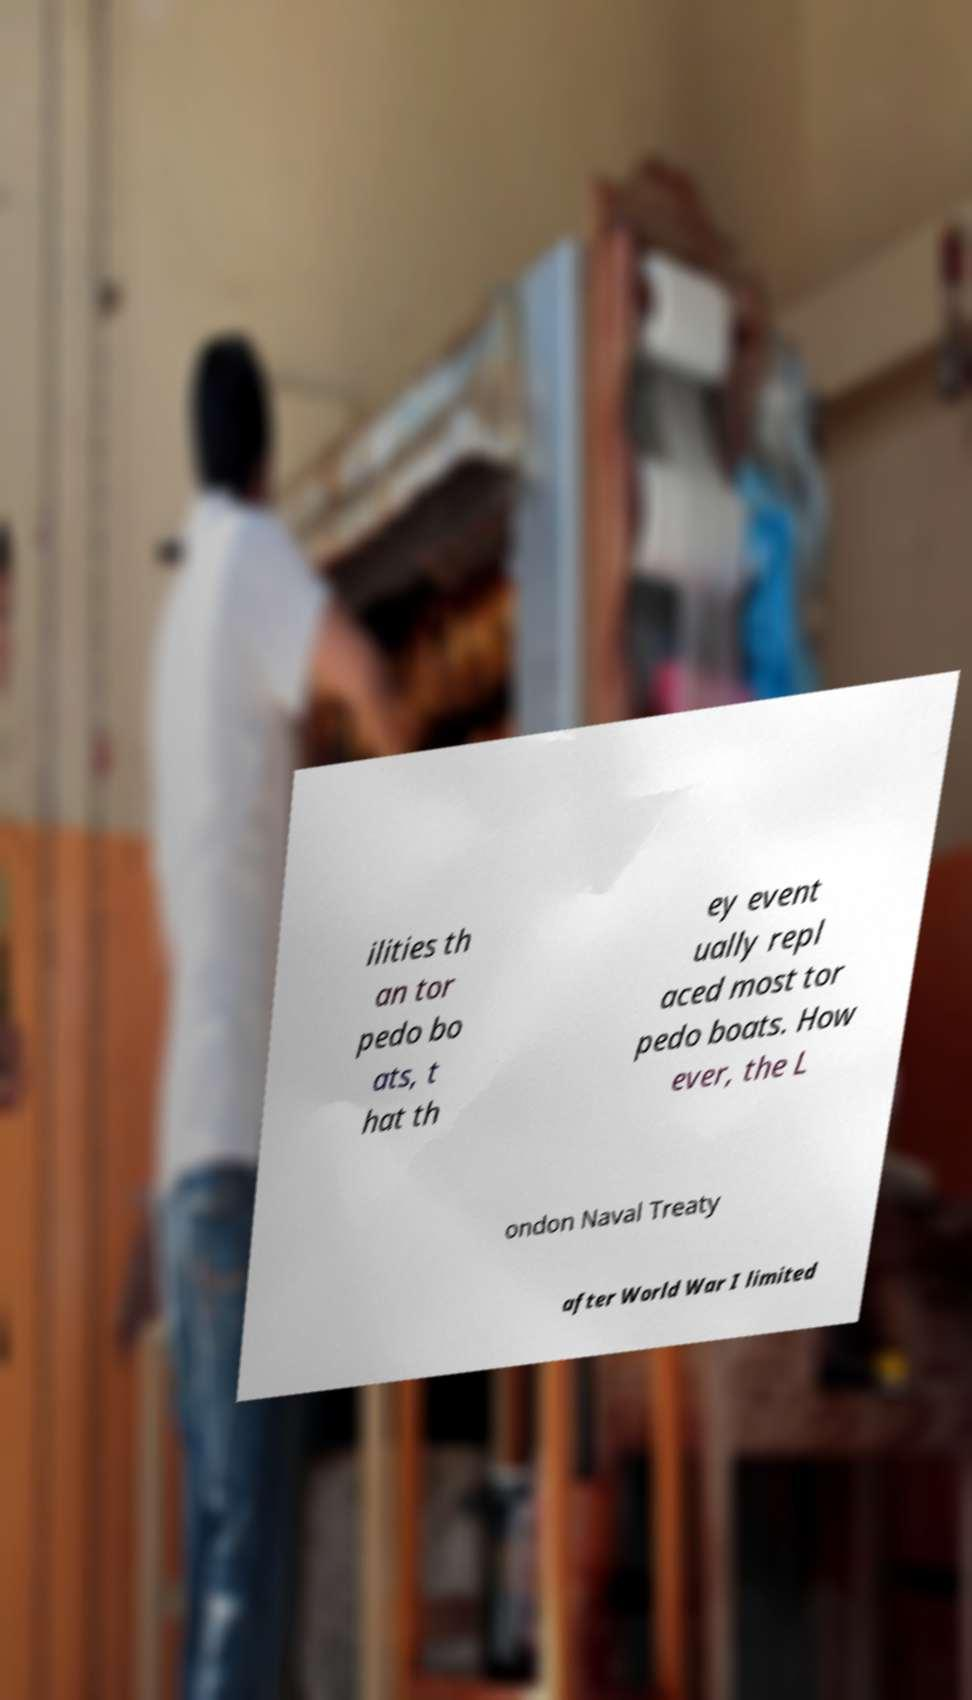I need the written content from this picture converted into text. Can you do that? ilities th an tor pedo bo ats, t hat th ey event ually repl aced most tor pedo boats. How ever, the L ondon Naval Treaty after World War I limited 